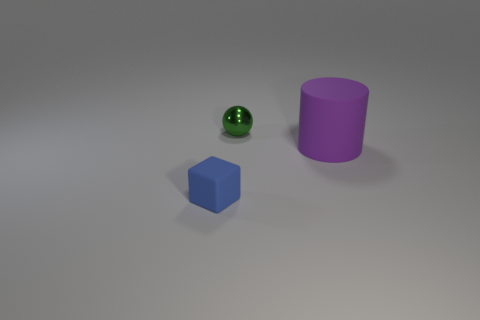Add 2 rubber cubes. How many objects exist? 5 Subtract 1 cylinders. How many cylinders are left? 0 Subtract all big yellow rubber balls. Subtract all tiny shiny objects. How many objects are left? 2 Add 2 small blue rubber objects. How many small blue rubber objects are left? 3 Add 3 small metallic objects. How many small metallic objects exist? 4 Subtract 0 cyan balls. How many objects are left? 3 Subtract all spheres. How many objects are left? 2 Subtract all cyan cylinders. Subtract all gray balls. How many cylinders are left? 1 